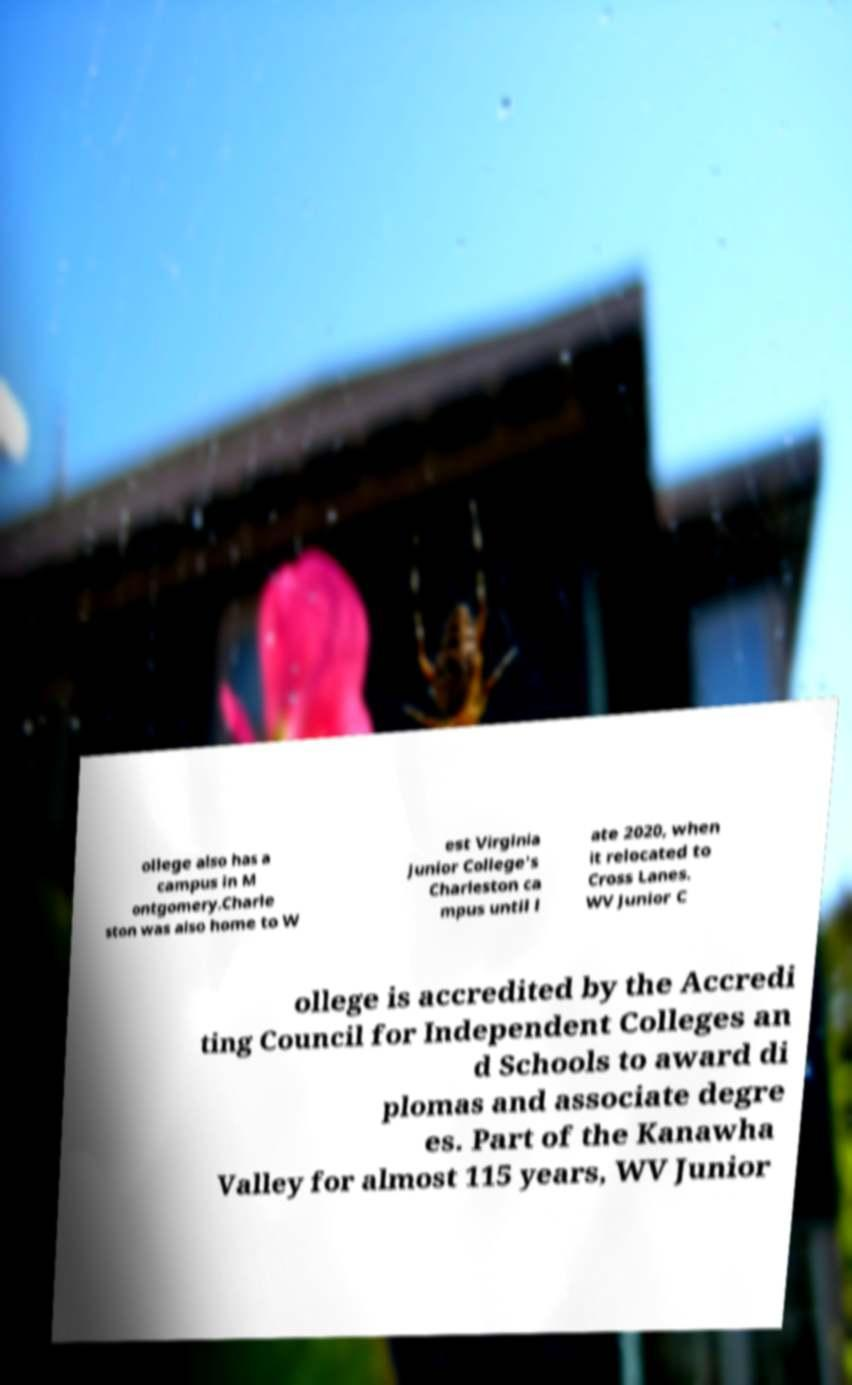Can you read and provide the text displayed in the image?This photo seems to have some interesting text. Can you extract and type it out for me? ollege also has a campus in M ontgomery.Charle ston was also home to W est Virginia Junior College's Charleston ca mpus until l ate 2020, when it relocated to Cross Lanes. WV Junior C ollege is accredited by the Accredi ting Council for Independent Colleges an d Schools to award di plomas and associate degre es. Part of the Kanawha Valley for almost 115 years, WV Junior 